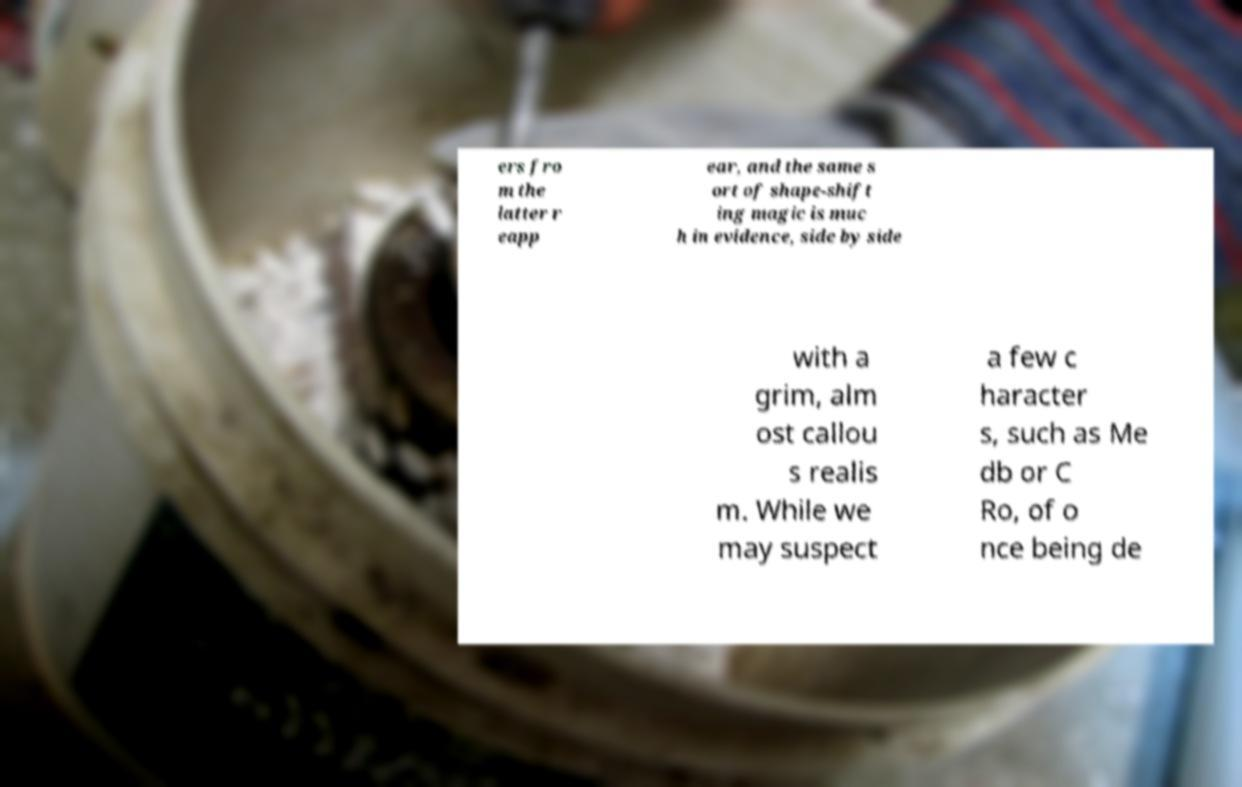What messages or text are displayed in this image? I need them in a readable, typed format. ers fro m the latter r eapp ear, and the same s ort of shape-shift ing magic is muc h in evidence, side by side with a grim, alm ost callou s realis m. While we may suspect a few c haracter s, such as Me db or C Ro, of o nce being de 